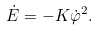<formula> <loc_0><loc_0><loc_500><loc_500>\dot { E } = - K \dot { \varphi } ^ { 2 } .</formula> 